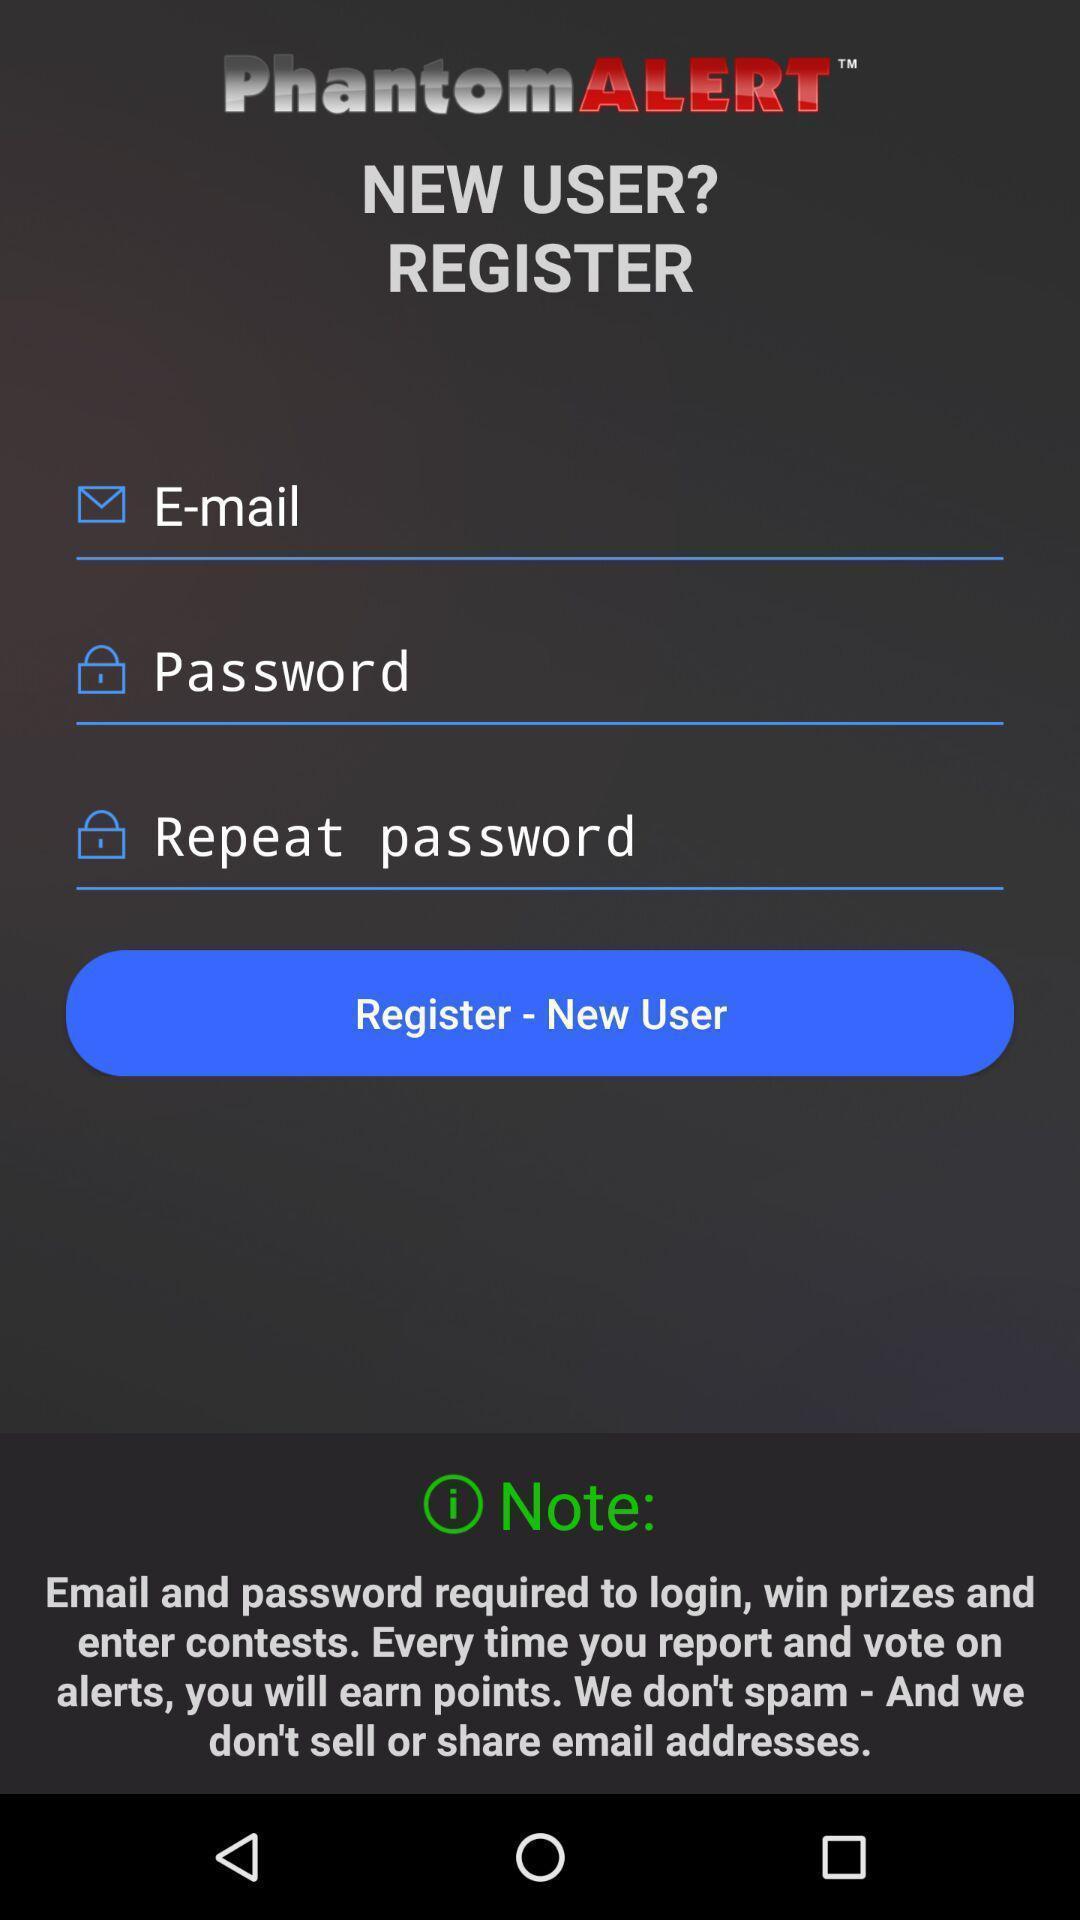Summarize the main components in this picture. Screen shows register new user details. 